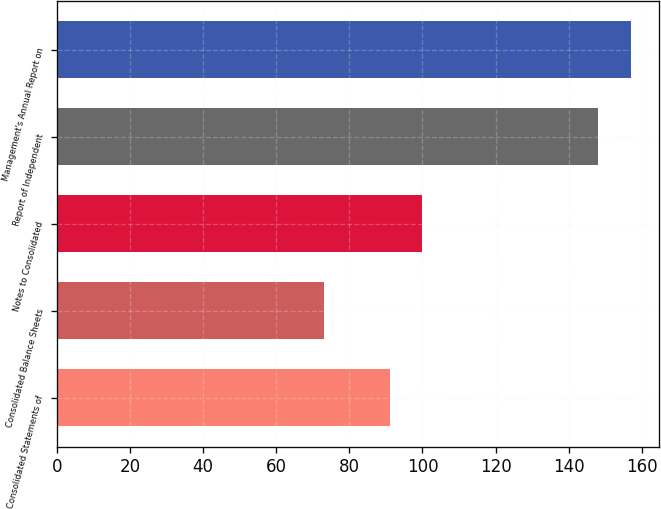<chart> <loc_0><loc_0><loc_500><loc_500><bar_chart><fcel>Consolidated Statements of<fcel>Consolidated Balance Sheets<fcel>Notes to Consolidated<fcel>Report of Independent<fcel>Management's Annual Report on<nl><fcel>91<fcel>73<fcel>100<fcel>148<fcel>157<nl></chart> 